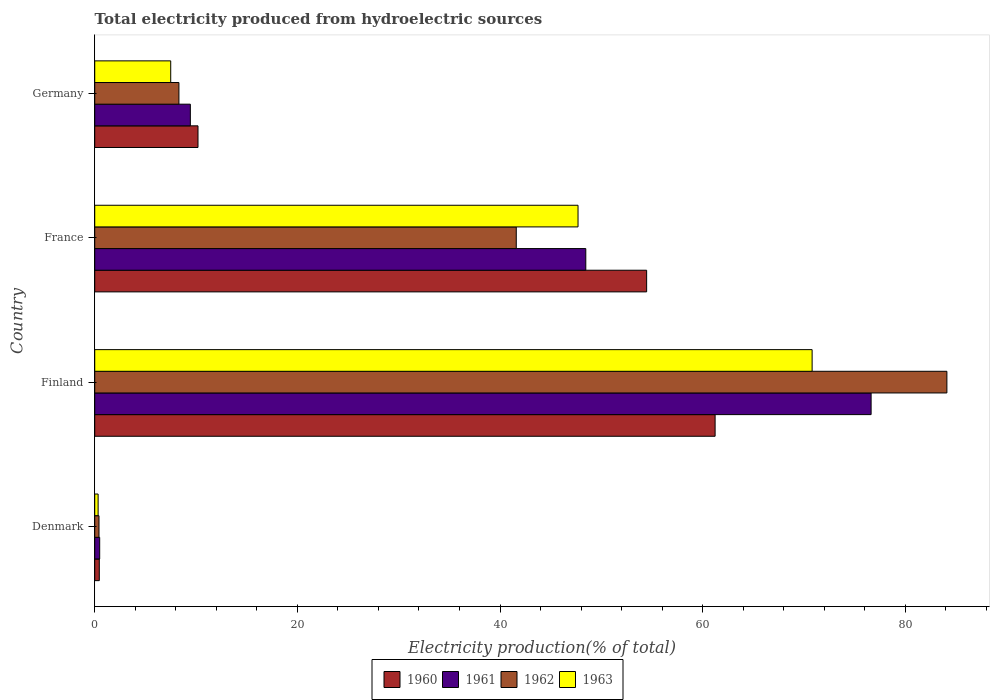How many different coloured bars are there?
Provide a short and direct response. 4. Are the number of bars per tick equal to the number of legend labels?
Keep it short and to the point. Yes. How many bars are there on the 2nd tick from the top?
Offer a terse response. 4. How many bars are there on the 3rd tick from the bottom?
Your response must be concise. 4. What is the label of the 2nd group of bars from the top?
Your answer should be compact. France. In how many cases, is the number of bars for a given country not equal to the number of legend labels?
Provide a succinct answer. 0. What is the total electricity produced in 1963 in Finland?
Provide a short and direct response. 70.81. Across all countries, what is the maximum total electricity produced in 1963?
Offer a very short reply. 70.81. Across all countries, what is the minimum total electricity produced in 1963?
Your response must be concise. 0.33. What is the total total electricity produced in 1962 in the graph?
Keep it short and to the point. 134.44. What is the difference between the total electricity produced in 1963 in Denmark and that in Finland?
Make the answer very short. -70.47. What is the difference between the total electricity produced in 1960 in France and the total electricity produced in 1963 in Germany?
Provide a succinct answer. 46.97. What is the average total electricity produced in 1960 per country?
Keep it short and to the point. 31.59. What is the difference between the total electricity produced in 1963 and total electricity produced in 1961 in Finland?
Provide a short and direct response. -5.82. In how many countries, is the total electricity produced in 1963 greater than 52 %?
Offer a very short reply. 1. What is the ratio of the total electricity produced in 1961 in Finland to that in Germany?
Your answer should be compact. 8.12. Is the difference between the total electricity produced in 1963 in France and Germany greater than the difference between the total electricity produced in 1961 in France and Germany?
Ensure brevity in your answer.  Yes. What is the difference between the highest and the second highest total electricity produced in 1962?
Keep it short and to the point. 42.5. What is the difference between the highest and the lowest total electricity produced in 1960?
Your answer should be compact. 60.78. In how many countries, is the total electricity produced in 1961 greater than the average total electricity produced in 1961 taken over all countries?
Your answer should be compact. 2. Is the sum of the total electricity produced in 1961 in Finland and France greater than the maximum total electricity produced in 1963 across all countries?
Ensure brevity in your answer.  Yes. Is it the case that in every country, the sum of the total electricity produced in 1961 and total electricity produced in 1962 is greater than the sum of total electricity produced in 1963 and total electricity produced in 1960?
Provide a short and direct response. No. How many bars are there?
Keep it short and to the point. 16. What is the difference between two consecutive major ticks on the X-axis?
Offer a very short reply. 20. Are the values on the major ticks of X-axis written in scientific E-notation?
Provide a short and direct response. No. Does the graph contain any zero values?
Ensure brevity in your answer.  No. Where does the legend appear in the graph?
Your answer should be very brief. Bottom center. What is the title of the graph?
Offer a very short reply. Total electricity produced from hydroelectric sources. What is the label or title of the Y-axis?
Give a very brief answer. Country. What is the Electricity production(% of total) of 1960 in Denmark?
Your response must be concise. 0.45. What is the Electricity production(% of total) of 1961 in Denmark?
Keep it short and to the point. 0.49. What is the Electricity production(% of total) in 1962 in Denmark?
Provide a succinct answer. 0.42. What is the Electricity production(% of total) of 1963 in Denmark?
Keep it short and to the point. 0.33. What is the Electricity production(% of total) in 1960 in Finland?
Give a very brief answer. 61.23. What is the Electricity production(% of total) of 1961 in Finland?
Make the answer very short. 76.63. What is the Electricity production(% of total) in 1962 in Finland?
Your answer should be very brief. 84.11. What is the Electricity production(% of total) in 1963 in Finland?
Offer a terse response. 70.81. What is the Electricity production(% of total) in 1960 in France?
Your answer should be very brief. 54.47. What is the Electricity production(% of total) in 1961 in France?
Give a very brief answer. 48.47. What is the Electricity production(% of total) in 1962 in France?
Provide a succinct answer. 41.61. What is the Electricity production(% of total) of 1963 in France?
Provide a short and direct response. 47.7. What is the Electricity production(% of total) in 1960 in Germany?
Your response must be concise. 10.19. What is the Electricity production(% of total) of 1961 in Germany?
Offer a very short reply. 9.44. What is the Electricity production(% of total) of 1962 in Germany?
Your answer should be very brief. 8.31. What is the Electricity production(% of total) of 1963 in Germany?
Make the answer very short. 7.5. Across all countries, what is the maximum Electricity production(% of total) of 1960?
Give a very brief answer. 61.23. Across all countries, what is the maximum Electricity production(% of total) of 1961?
Offer a very short reply. 76.63. Across all countries, what is the maximum Electricity production(% of total) in 1962?
Offer a terse response. 84.11. Across all countries, what is the maximum Electricity production(% of total) of 1963?
Ensure brevity in your answer.  70.81. Across all countries, what is the minimum Electricity production(% of total) of 1960?
Give a very brief answer. 0.45. Across all countries, what is the minimum Electricity production(% of total) in 1961?
Provide a succinct answer. 0.49. Across all countries, what is the minimum Electricity production(% of total) of 1962?
Keep it short and to the point. 0.42. Across all countries, what is the minimum Electricity production(% of total) of 1963?
Ensure brevity in your answer.  0.33. What is the total Electricity production(% of total) of 1960 in the graph?
Ensure brevity in your answer.  126.35. What is the total Electricity production(% of total) of 1961 in the graph?
Your answer should be very brief. 135.02. What is the total Electricity production(% of total) of 1962 in the graph?
Offer a terse response. 134.44. What is the total Electricity production(% of total) in 1963 in the graph?
Keep it short and to the point. 126.34. What is the difference between the Electricity production(% of total) of 1960 in Denmark and that in Finland?
Your answer should be very brief. -60.78. What is the difference between the Electricity production(% of total) in 1961 in Denmark and that in Finland?
Your answer should be compact. -76.14. What is the difference between the Electricity production(% of total) in 1962 in Denmark and that in Finland?
Offer a very short reply. -83.69. What is the difference between the Electricity production(% of total) of 1963 in Denmark and that in Finland?
Offer a terse response. -70.47. What is the difference between the Electricity production(% of total) of 1960 in Denmark and that in France?
Keep it short and to the point. -54.02. What is the difference between the Electricity production(% of total) of 1961 in Denmark and that in France?
Offer a very short reply. -47.98. What is the difference between the Electricity production(% of total) of 1962 in Denmark and that in France?
Offer a very short reply. -41.18. What is the difference between the Electricity production(% of total) in 1963 in Denmark and that in France?
Your response must be concise. -47.37. What is the difference between the Electricity production(% of total) of 1960 in Denmark and that in Germany?
Offer a very short reply. -9.74. What is the difference between the Electricity production(% of total) of 1961 in Denmark and that in Germany?
Your answer should be compact. -8.95. What is the difference between the Electricity production(% of total) of 1962 in Denmark and that in Germany?
Your answer should be compact. -7.89. What is the difference between the Electricity production(% of total) in 1963 in Denmark and that in Germany?
Provide a succinct answer. -7.17. What is the difference between the Electricity production(% of total) in 1960 in Finland and that in France?
Ensure brevity in your answer.  6.76. What is the difference between the Electricity production(% of total) in 1961 in Finland and that in France?
Give a very brief answer. 28.16. What is the difference between the Electricity production(% of total) of 1962 in Finland and that in France?
Provide a succinct answer. 42.5. What is the difference between the Electricity production(% of total) of 1963 in Finland and that in France?
Make the answer very short. 23.11. What is the difference between the Electricity production(% of total) of 1960 in Finland and that in Germany?
Your response must be concise. 51.04. What is the difference between the Electricity production(% of total) in 1961 in Finland and that in Germany?
Your answer should be compact. 67.19. What is the difference between the Electricity production(% of total) of 1962 in Finland and that in Germany?
Your answer should be compact. 75.8. What is the difference between the Electricity production(% of total) of 1963 in Finland and that in Germany?
Ensure brevity in your answer.  63.31. What is the difference between the Electricity production(% of total) of 1960 in France and that in Germany?
Your answer should be very brief. 44.28. What is the difference between the Electricity production(% of total) in 1961 in France and that in Germany?
Provide a succinct answer. 39.03. What is the difference between the Electricity production(% of total) in 1962 in France and that in Germany?
Your answer should be compact. 33.3. What is the difference between the Electricity production(% of total) in 1963 in France and that in Germany?
Your answer should be compact. 40.2. What is the difference between the Electricity production(% of total) in 1960 in Denmark and the Electricity production(% of total) in 1961 in Finland?
Provide a short and direct response. -76.18. What is the difference between the Electricity production(% of total) of 1960 in Denmark and the Electricity production(% of total) of 1962 in Finland?
Your answer should be very brief. -83.66. What is the difference between the Electricity production(% of total) in 1960 in Denmark and the Electricity production(% of total) in 1963 in Finland?
Give a very brief answer. -70.36. What is the difference between the Electricity production(% of total) of 1961 in Denmark and the Electricity production(% of total) of 1962 in Finland?
Offer a very short reply. -83.62. What is the difference between the Electricity production(% of total) of 1961 in Denmark and the Electricity production(% of total) of 1963 in Finland?
Your answer should be very brief. -70.32. What is the difference between the Electricity production(% of total) in 1962 in Denmark and the Electricity production(% of total) in 1963 in Finland?
Your answer should be compact. -70.39. What is the difference between the Electricity production(% of total) of 1960 in Denmark and the Electricity production(% of total) of 1961 in France?
Ensure brevity in your answer.  -48.02. What is the difference between the Electricity production(% of total) of 1960 in Denmark and the Electricity production(% of total) of 1962 in France?
Provide a short and direct response. -41.15. What is the difference between the Electricity production(% of total) of 1960 in Denmark and the Electricity production(% of total) of 1963 in France?
Keep it short and to the point. -47.25. What is the difference between the Electricity production(% of total) in 1961 in Denmark and the Electricity production(% of total) in 1962 in France?
Ensure brevity in your answer.  -41.12. What is the difference between the Electricity production(% of total) of 1961 in Denmark and the Electricity production(% of total) of 1963 in France?
Your answer should be compact. -47.21. What is the difference between the Electricity production(% of total) of 1962 in Denmark and the Electricity production(% of total) of 1963 in France?
Give a very brief answer. -47.28. What is the difference between the Electricity production(% of total) of 1960 in Denmark and the Electricity production(% of total) of 1961 in Germany?
Provide a short and direct response. -8.99. What is the difference between the Electricity production(% of total) of 1960 in Denmark and the Electricity production(% of total) of 1962 in Germany?
Ensure brevity in your answer.  -7.86. What is the difference between the Electricity production(% of total) in 1960 in Denmark and the Electricity production(% of total) in 1963 in Germany?
Provide a short and direct response. -7.05. What is the difference between the Electricity production(% of total) of 1961 in Denmark and the Electricity production(% of total) of 1962 in Germany?
Offer a very short reply. -7.82. What is the difference between the Electricity production(% of total) in 1961 in Denmark and the Electricity production(% of total) in 1963 in Germany?
Offer a very short reply. -7.01. What is the difference between the Electricity production(% of total) of 1962 in Denmark and the Electricity production(% of total) of 1963 in Germany?
Give a very brief answer. -7.08. What is the difference between the Electricity production(% of total) in 1960 in Finland and the Electricity production(% of total) in 1961 in France?
Your response must be concise. 12.76. What is the difference between the Electricity production(% of total) of 1960 in Finland and the Electricity production(% of total) of 1962 in France?
Make the answer very short. 19.63. What is the difference between the Electricity production(% of total) of 1960 in Finland and the Electricity production(% of total) of 1963 in France?
Offer a terse response. 13.53. What is the difference between the Electricity production(% of total) of 1961 in Finland and the Electricity production(% of total) of 1962 in France?
Give a very brief answer. 35.02. What is the difference between the Electricity production(% of total) of 1961 in Finland and the Electricity production(% of total) of 1963 in France?
Your answer should be very brief. 28.93. What is the difference between the Electricity production(% of total) of 1962 in Finland and the Electricity production(% of total) of 1963 in France?
Your answer should be compact. 36.41. What is the difference between the Electricity production(% of total) of 1960 in Finland and the Electricity production(% of total) of 1961 in Germany?
Provide a succinct answer. 51.8. What is the difference between the Electricity production(% of total) of 1960 in Finland and the Electricity production(% of total) of 1962 in Germany?
Give a very brief answer. 52.92. What is the difference between the Electricity production(% of total) of 1960 in Finland and the Electricity production(% of total) of 1963 in Germany?
Provide a short and direct response. 53.73. What is the difference between the Electricity production(% of total) of 1961 in Finland and the Electricity production(% of total) of 1962 in Germany?
Your answer should be compact. 68.32. What is the difference between the Electricity production(% of total) of 1961 in Finland and the Electricity production(% of total) of 1963 in Germany?
Your response must be concise. 69.13. What is the difference between the Electricity production(% of total) of 1962 in Finland and the Electricity production(% of total) of 1963 in Germany?
Provide a short and direct response. 76.61. What is the difference between the Electricity production(% of total) of 1960 in France and the Electricity production(% of total) of 1961 in Germany?
Your response must be concise. 45.04. What is the difference between the Electricity production(% of total) of 1960 in France and the Electricity production(% of total) of 1962 in Germany?
Provide a succinct answer. 46.16. What is the difference between the Electricity production(% of total) of 1960 in France and the Electricity production(% of total) of 1963 in Germany?
Offer a terse response. 46.97. What is the difference between the Electricity production(% of total) in 1961 in France and the Electricity production(% of total) in 1962 in Germany?
Your answer should be compact. 40.16. What is the difference between the Electricity production(% of total) of 1961 in France and the Electricity production(% of total) of 1963 in Germany?
Provide a short and direct response. 40.97. What is the difference between the Electricity production(% of total) in 1962 in France and the Electricity production(% of total) in 1963 in Germany?
Your answer should be very brief. 34.11. What is the average Electricity production(% of total) in 1960 per country?
Make the answer very short. 31.59. What is the average Electricity production(% of total) of 1961 per country?
Provide a short and direct response. 33.76. What is the average Electricity production(% of total) of 1962 per country?
Make the answer very short. 33.61. What is the average Electricity production(% of total) of 1963 per country?
Ensure brevity in your answer.  31.59. What is the difference between the Electricity production(% of total) in 1960 and Electricity production(% of total) in 1961 in Denmark?
Give a very brief answer. -0.04. What is the difference between the Electricity production(% of total) in 1960 and Electricity production(% of total) in 1962 in Denmark?
Make the answer very short. 0.03. What is the difference between the Electricity production(% of total) in 1960 and Electricity production(% of total) in 1963 in Denmark?
Give a very brief answer. 0.12. What is the difference between the Electricity production(% of total) of 1961 and Electricity production(% of total) of 1962 in Denmark?
Offer a very short reply. 0.07. What is the difference between the Electricity production(% of total) in 1961 and Electricity production(% of total) in 1963 in Denmark?
Make the answer very short. 0.15. What is the difference between the Electricity production(% of total) in 1962 and Electricity production(% of total) in 1963 in Denmark?
Provide a succinct answer. 0.09. What is the difference between the Electricity production(% of total) in 1960 and Electricity production(% of total) in 1961 in Finland?
Your answer should be very brief. -15.4. What is the difference between the Electricity production(% of total) in 1960 and Electricity production(% of total) in 1962 in Finland?
Ensure brevity in your answer.  -22.88. What is the difference between the Electricity production(% of total) in 1960 and Electricity production(% of total) in 1963 in Finland?
Provide a short and direct response. -9.58. What is the difference between the Electricity production(% of total) in 1961 and Electricity production(% of total) in 1962 in Finland?
Provide a short and direct response. -7.48. What is the difference between the Electricity production(% of total) of 1961 and Electricity production(% of total) of 1963 in Finland?
Give a very brief answer. 5.82. What is the difference between the Electricity production(% of total) in 1962 and Electricity production(% of total) in 1963 in Finland?
Make the answer very short. 13.3. What is the difference between the Electricity production(% of total) in 1960 and Electricity production(% of total) in 1961 in France?
Your answer should be compact. 6.01. What is the difference between the Electricity production(% of total) in 1960 and Electricity production(% of total) in 1962 in France?
Ensure brevity in your answer.  12.87. What is the difference between the Electricity production(% of total) in 1960 and Electricity production(% of total) in 1963 in France?
Your answer should be compact. 6.77. What is the difference between the Electricity production(% of total) of 1961 and Electricity production(% of total) of 1962 in France?
Provide a short and direct response. 6.86. What is the difference between the Electricity production(% of total) in 1961 and Electricity production(% of total) in 1963 in France?
Provide a short and direct response. 0.77. What is the difference between the Electricity production(% of total) of 1962 and Electricity production(% of total) of 1963 in France?
Ensure brevity in your answer.  -6.1. What is the difference between the Electricity production(% of total) in 1960 and Electricity production(% of total) in 1961 in Germany?
Provide a succinct answer. 0.76. What is the difference between the Electricity production(% of total) in 1960 and Electricity production(% of total) in 1962 in Germany?
Provide a succinct answer. 1.88. What is the difference between the Electricity production(% of total) in 1960 and Electricity production(% of total) in 1963 in Germany?
Provide a short and direct response. 2.69. What is the difference between the Electricity production(% of total) in 1961 and Electricity production(% of total) in 1962 in Germany?
Offer a terse response. 1.13. What is the difference between the Electricity production(% of total) of 1961 and Electricity production(% of total) of 1963 in Germany?
Make the answer very short. 1.94. What is the difference between the Electricity production(% of total) of 1962 and Electricity production(% of total) of 1963 in Germany?
Your answer should be compact. 0.81. What is the ratio of the Electricity production(% of total) of 1960 in Denmark to that in Finland?
Give a very brief answer. 0.01. What is the ratio of the Electricity production(% of total) in 1961 in Denmark to that in Finland?
Give a very brief answer. 0.01. What is the ratio of the Electricity production(% of total) in 1962 in Denmark to that in Finland?
Give a very brief answer. 0.01. What is the ratio of the Electricity production(% of total) of 1963 in Denmark to that in Finland?
Provide a short and direct response. 0. What is the ratio of the Electricity production(% of total) of 1960 in Denmark to that in France?
Your response must be concise. 0.01. What is the ratio of the Electricity production(% of total) in 1961 in Denmark to that in France?
Ensure brevity in your answer.  0.01. What is the ratio of the Electricity production(% of total) in 1962 in Denmark to that in France?
Your answer should be compact. 0.01. What is the ratio of the Electricity production(% of total) in 1963 in Denmark to that in France?
Make the answer very short. 0.01. What is the ratio of the Electricity production(% of total) of 1960 in Denmark to that in Germany?
Offer a terse response. 0.04. What is the ratio of the Electricity production(% of total) in 1961 in Denmark to that in Germany?
Your response must be concise. 0.05. What is the ratio of the Electricity production(% of total) in 1962 in Denmark to that in Germany?
Give a very brief answer. 0.05. What is the ratio of the Electricity production(% of total) of 1963 in Denmark to that in Germany?
Provide a succinct answer. 0.04. What is the ratio of the Electricity production(% of total) of 1960 in Finland to that in France?
Your response must be concise. 1.12. What is the ratio of the Electricity production(% of total) in 1961 in Finland to that in France?
Offer a terse response. 1.58. What is the ratio of the Electricity production(% of total) of 1962 in Finland to that in France?
Make the answer very short. 2.02. What is the ratio of the Electricity production(% of total) in 1963 in Finland to that in France?
Your answer should be very brief. 1.48. What is the ratio of the Electricity production(% of total) of 1960 in Finland to that in Germany?
Your answer should be compact. 6.01. What is the ratio of the Electricity production(% of total) in 1961 in Finland to that in Germany?
Provide a short and direct response. 8.12. What is the ratio of the Electricity production(% of total) of 1962 in Finland to that in Germany?
Keep it short and to the point. 10.12. What is the ratio of the Electricity production(% of total) of 1963 in Finland to that in Germany?
Ensure brevity in your answer.  9.44. What is the ratio of the Electricity production(% of total) in 1960 in France to that in Germany?
Provide a succinct answer. 5.34. What is the ratio of the Electricity production(% of total) in 1961 in France to that in Germany?
Provide a succinct answer. 5.14. What is the ratio of the Electricity production(% of total) in 1962 in France to that in Germany?
Your answer should be very brief. 5.01. What is the ratio of the Electricity production(% of total) of 1963 in France to that in Germany?
Give a very brief answer. 6.36. What is the difference between the highest and the second highest Electricity production(% of total) of 1960?
Offer a very short reply. 6.76. What is the difference between the highest and the second highest Electricity production(% of total) of 1961?
Keep it short and to the point. 28.16. What is the difference between the highest and the second highest Electricity production(% of total) of 1962?
Ensure brevity in your answer.  42.5. What is the difference between the highest and the second highest Electricity production(% of total) of 1963?
Provide a short and direct response. 23.11. What is the difference between the highest and the lowest Electricity production(% of total) in 1960?
Give a very brief answer. 60.78. What is the difference between the highest and the lowest Electricity production(% of total) of 1961?
Make the answer very short. 76.14. What is the difference between the highest and the lowest Electricity production(% of total) of 1962?
Give a very brief answer. 83.69. What is the difference between the highest and the lowest Electricity production(% of total) of 1963?
Give a very brief answer. 70.47. 